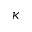Convert formula to latex. <formula><loc_0><loc_0><loc_500><loc_500>\kappa</formula> 